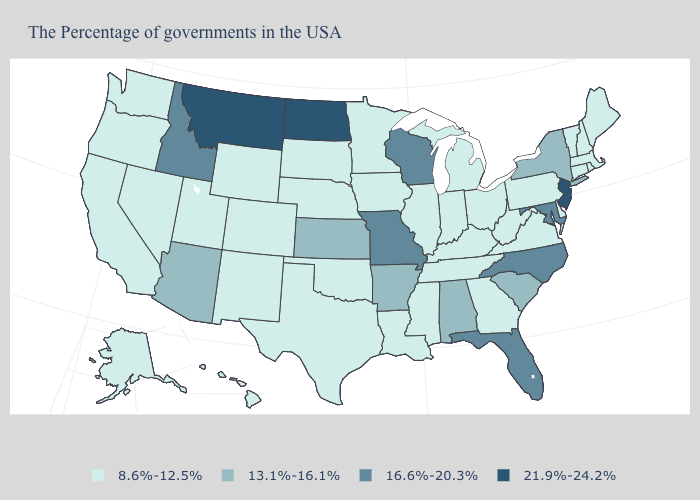Does New Jersey have the highest value in the Northeast?
Write a very short answer. Yes. What is the value of New York?
Be succinct. 13.1%-16.1%. Which states have the lowest value in the Northeast?
Give a very brief answer. Maine, Massachusetts, Rhode Island, New Hampshire, Vermont, Connecticut, Pennsylvania. What is the value of South Dakota?
Short answer required. 8.6%-12.5%. Among the states that border New Mexico , which have the lowest value?
Write a very short answer. Oklahoma, Texas, Colorado, Utah. What is the value of Colorado?
Short answer required. 8.6%-12.5%. Among the states that border Rhode Island , which have the lowest value?
Short answer required. Massachusetts, Connecticut. Does Montana have the lowest value in the USA?
Answer briefly. No. Does the map have missing data?
Be succinct. No. Among the states that border Oregon , which have the lowest value?
Keep it brief. Nevada, California, Washington. Name the states that have a value in the range 16.6%-20.3%?
Give a very brief answer. Maryland, North Carolina, Florida, Wisconsin, Missouri, Idaho. Among the states that border Kentucky , does Missouri have the lowest value?
Write a very short answer. No. What is the value of Alaska?
Concise answer only. 8.6%-12.5%. Which states have the lowest value in the USA?
Concise answer only. Maine, Massachusetts, Rhode Island, New Hampshire, Vermont, Connecticut, Delaware, Pennsylvania, Virginia, West Virginia, Ohio, Georgia, Michigan, Kentucky, Indiana, Tennessee, Illinois, Mississippi, Louisiana, Minnesota, Iowa, Nebraska, Oklahoma, Texas, South Dakota, Wyoming, Colorado, New Mexico, Utah, Nevada, California, Washington, Oregon, Alaska, Hawaii. Among the states that border Kansas , does Missouri have the highest value?
Keep it brief. Yes. 